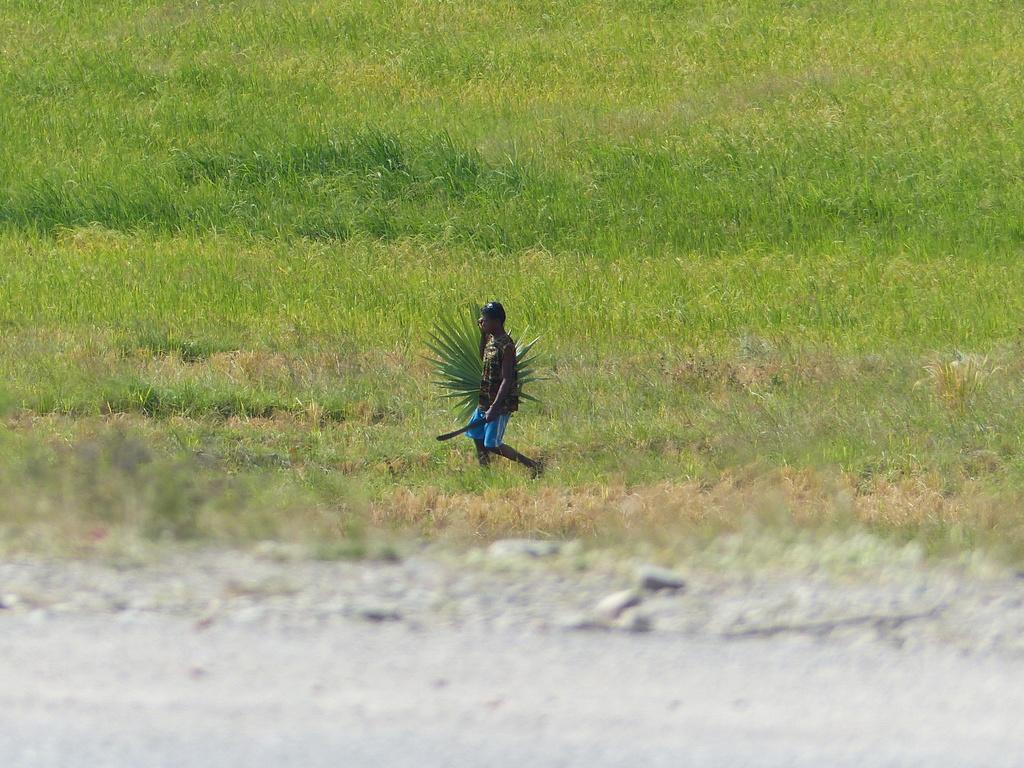How would you summarize this image in a sentence or two? In this image in the center there is a man holding an object which is green in colour and walking. In the background there is grass on the ground. 